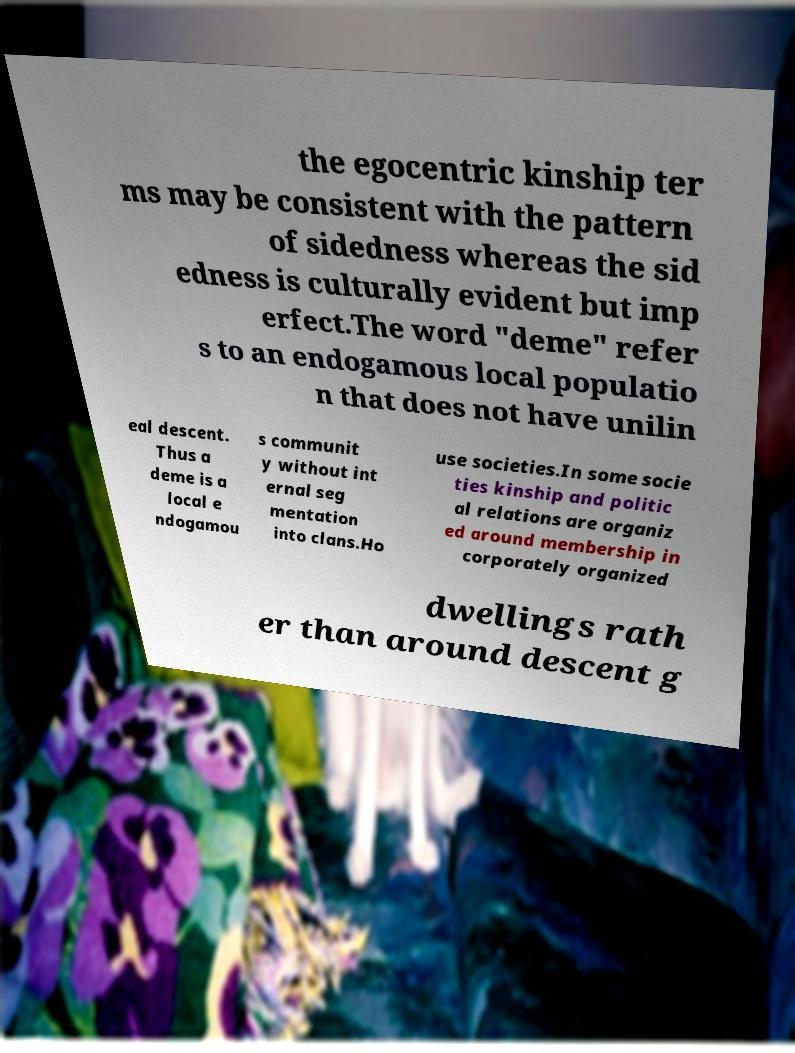Can you accurately transcribe the text from the provided image for me? the egocentric kinship ter ms may be consistent with the pattern of sidedness whereas the sid edness is culturally evident but imp erfect.The word "deme" refer s to an endogamous local populatio n that does not have unilin eal descent. Thus a deme is a local e ndogamou s communit y without int ernal seg mentation into clans.Ho use societies.In some socie ties kinship and politic al relations are organiz ed around membership in corporately organized dwellings rath er than around descent g 